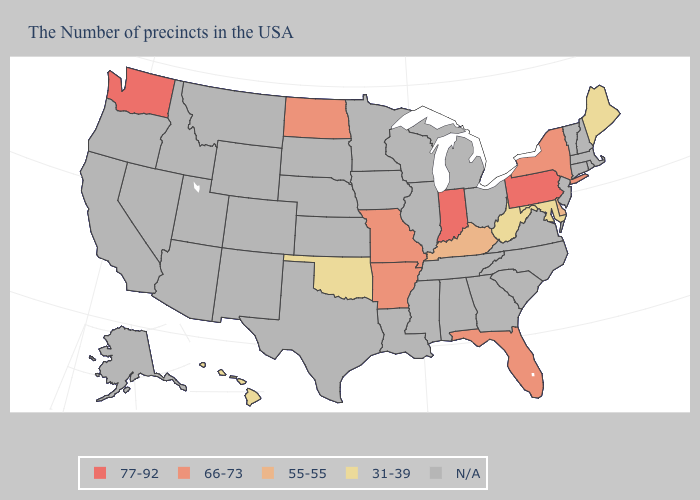What is the highest value in states that border Colorado?
Quick response, please. 31-39. What is the value of Arkansas?
Short answer required. 66-73. What is the lowest value in the USA?
Be succinct. 31-39. Name the states that have a value in the range 31-39?
Answer briefly. Maine, Maryland, West Virginia, Oklahoma, Hawaii. Which states have the lowest value in the USA?
Be succinct. Maine, Maryland, West Virginia, Oklahoma, Hawaii. Which states have the lowest value in the West?
Keep it brief. Hawaii. Does Kentucky have the highest value in the South?
Quick response, please. No. Does Maine have the lowest value in the USA?
Quick response, please. Yes. What is the value of California?
Be succinct. N/A. Does Pennsylvania have the highest value in the USA?
Write a very short answer. Yes. Name the states that have a value in the range 77-92?
Give a very brief answer. Pennsylvania, Indiana, Washington. Name the states that have a value in the range N/A?
Short answer required. Massachusetts, Rhode Island, New Hampshire, Vermont, Connecticut, New Jersey, Virginia, North Carolina, South Carolina, Ohio, Georgia, Michigan, Alabama, Tennessee, Wisconsin, Illinois, Mississippi, Louisiana, Minnesota, Iowa, Kansas, Nebraska, Texas, South Dakota, Wyoming, Colorado, New Mexico, Utah, Montana, Arizona, Idaho, Nevada, California, Oregon, Alaska. What is the value of New Jersey?
Write a very short answer. N/A. Name the states that have a value in the range 55-55?
Answer briefly. Delaware, Kentucky. 